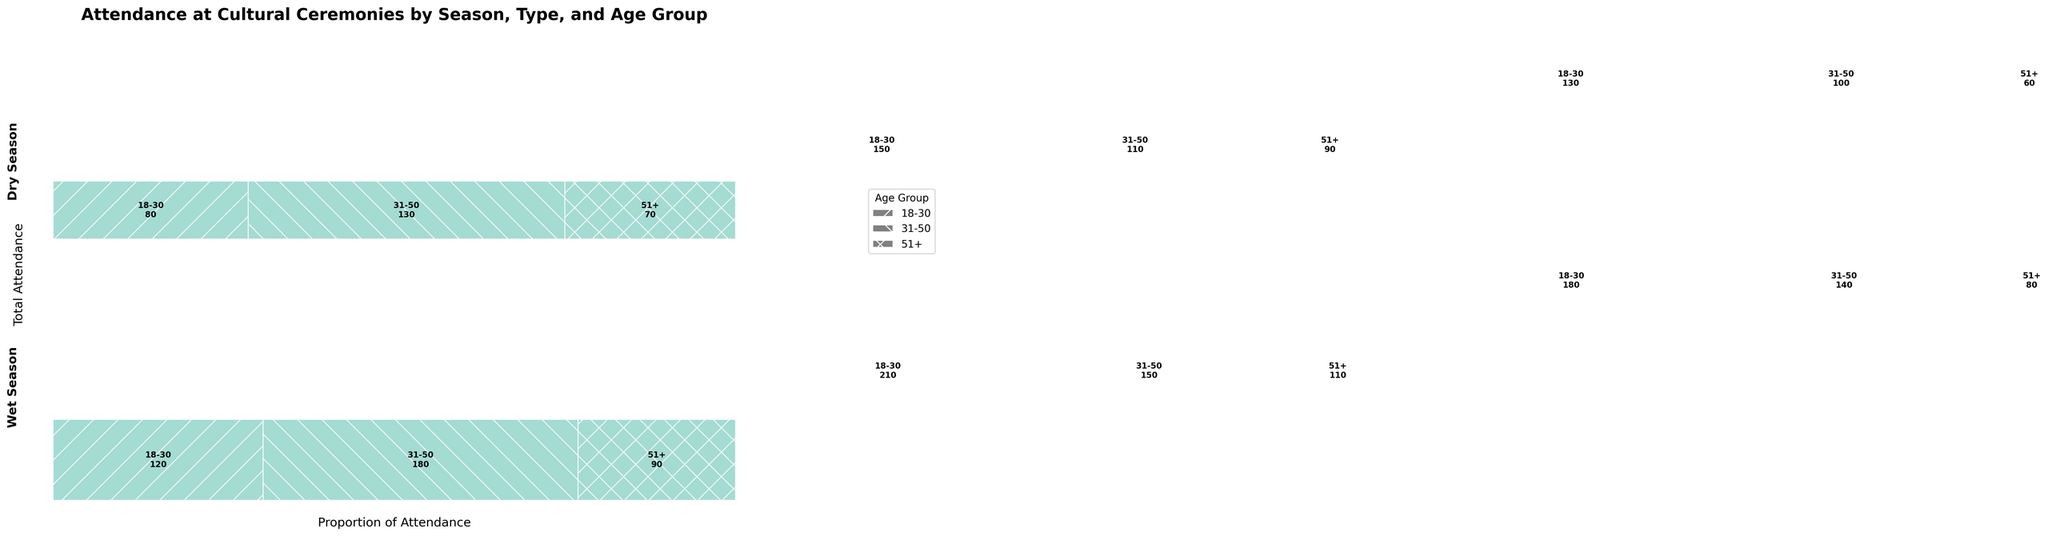What is the title of the figure? The title is usually located at the top of the plot. In this case, it says "Attendance at Cultural Ceremonies by Season, Type, and Age Group."
Answer: Attendance at Cultural Ceremonies by Season, Type, and Age Group Which age group has the highest attendance for the Kava Ceremony during the dry season? Locate the dry season section and find the Kava Ceremony part. Check the rectangles representing different age groups, looking for the one with the largest area (height). It's '31-50' with 180 attendees.
Answer: 31-50 Is the attendance for Meke Dance higher in the dry season or wet season? Compare the total height of the rectangles for Meke Dance in both dry and wet sections. The dry season section has taller rectangles indicating higher attendance.
Answer: Dry season How many attendees aged 18-30 attended the Fire Walking ceremony in the wet season? Find the wet season section and locate the Fire Walking part. Look for the rectangle with the hatch pattern representing 18-30 and check the number inside or height proportion of the rectangle. It says "130."
Answer: 130 What is the total attendance of the Kava Ceremony during the wet season? Add up the attendance numbers for all age groups under the Kava Ceremony in the wet season. These are 80 (18-30), 130 (31-50), and 70 (51+), totaling 280.
Answer: 280 Which ceremony type has the least total attendance in the wet season? Compare the total height of the rectangles for each ceremony type within the wet season section. The Fire Walking section has the shortest total height, indicating the least attendance.
Answer: Fire Walking What's the total attendance for the Kava Ceremony across both seasons? Sum up the total attendance numbers for the Kava Ceremony in both seasons. For the dry season, it's 120 + 180 + 90 = 390; for the wet season, it's 80 + 130 + 70 = 280. In total, this is 390 + 280 = 670.
Answer: 670 How does the attendance for the Meke Dance ceremony for visitors aged 51+ compare between the wet and dry seasons? Compare the attendance numbers directly from the wet (90 attendees) and dry (110 attendees) seasons for the 51+ group in the Meke Dance section. The dry season has higher attendance.
Answer: Dry season higher Which ceremony type shows the largest attendance drop between the dry and wet seasons for visitors aged 31-50? Compare the attendance numbers for 31-50 across different ceremonies and seasons. The Kava Ceremony drops from 180 (dry) to 130 (wet), showing a drop of 50 attendees, which is the largest decrease compared to other ceremonies.
Answer: Kava Ceremony 